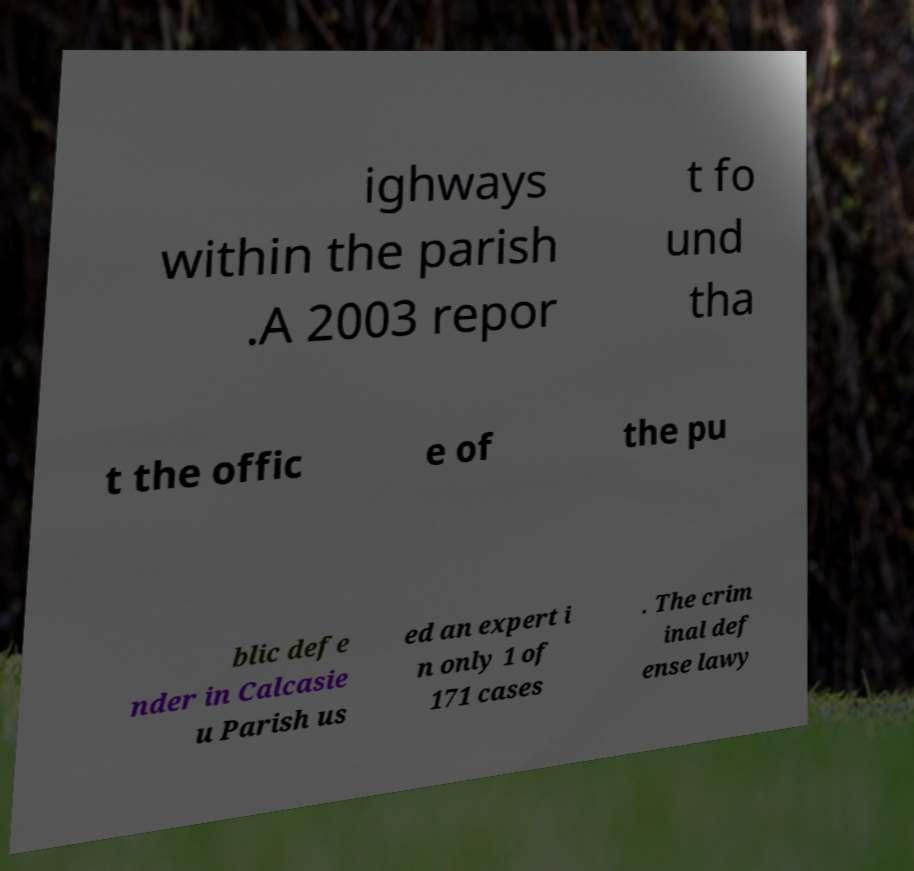Can you read and provide the text displayed in the image?This photo seems to have some interesting text. Can you extract and type it out for me? ighways within the parish .A 2003 repor t fo und tha t the offic e of the pu blic defe nder in Calcasie u Parish us ed an expert i n only 1 of 171 cases . The crim inal def ense lawy 